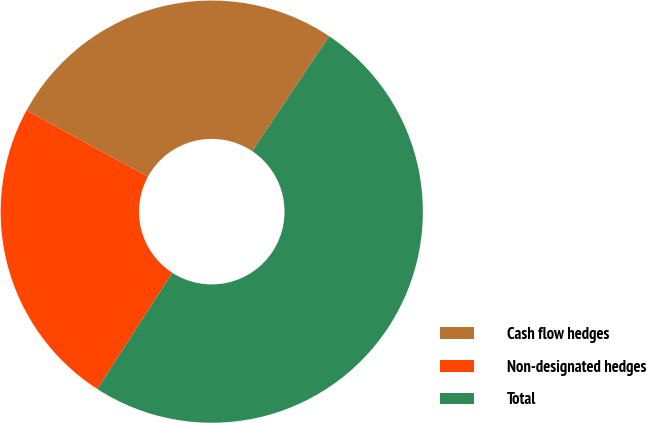Convert chart to OTSL. <chart><loc_0><loc_0><loc_500><loc_500><pie_chart><fcel>Cash flow hedges<fcel>Non-designated hedges<fcel>Total<nl><fcel>26.43%<fcel>23.84%<fcel>49.73%<nl></chart> 